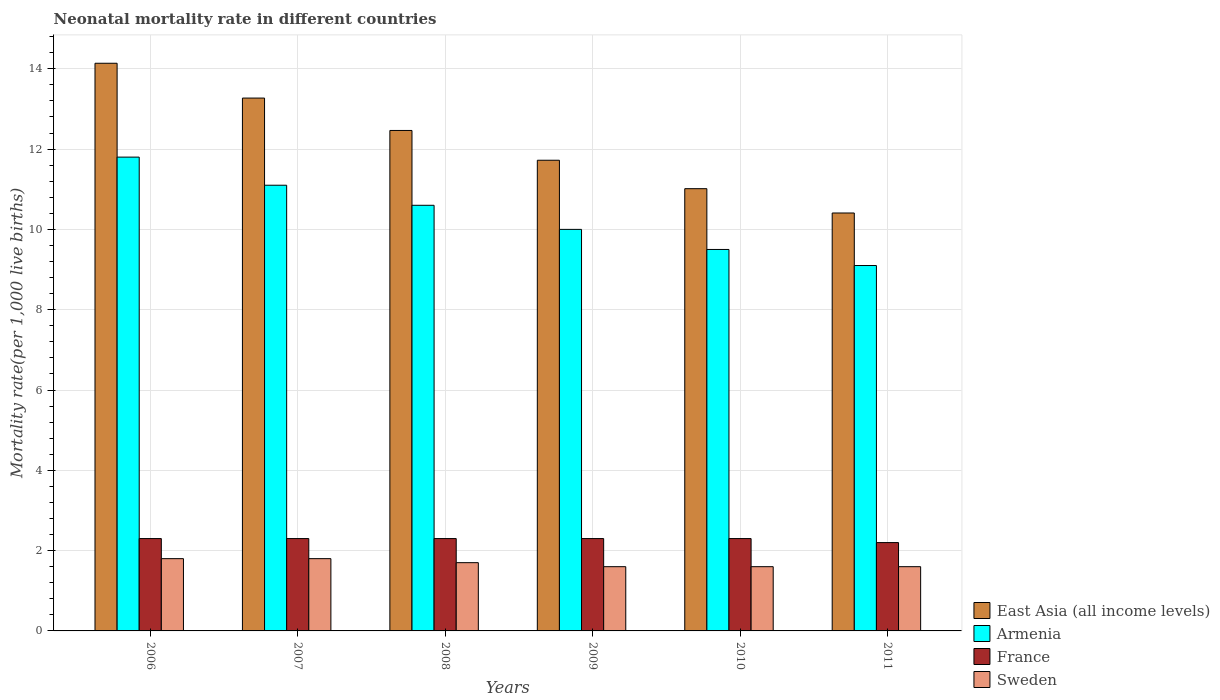How many different coloured bars are there?
Offer a very short reply. 4. How many groups of bars are there?
Keep it short and to the point. 6. How many bars are there on the 6th tick from the right?
Give a very brief answer. 4. What is the neonatal mortality rate in East Asia (all income levels) in 2006?
Provide a short and direct response. 14.14. Across all years, what is the minimum neonatal mortality rate in Armenia?
Your answer should be compact. 9.1. In which year was the neonatal mortality rate in Sweden maximum?
Your answer should be very brief. 2006. In which year was the neonatal mortality rate in France minimum?
Your response must be concise. 2011. What is the total neonatal mortality rate in East Asia (all income levels) in the graph?
Keep it short and to the point. 73.02. What is the difference between the neonatal mortality rate in France in 2008 and that in 2009?
Give a very brief answer. 0. What is the difference between the neonatal mortality rate in Sweden in 2010 and the neonatal mortality rate in Armenia in 2009?
Offer a terse response. -8.4. What is the average neonatal mortality rate in France per year?
Provide a succinct answer. 2.28. In the year 2011, what is the difference between the neonatal mortality rate in France and neonatal mortality rate in Armenia?
Provide a succinct answer. -6.9. In how many years, is the neonatal mortality rate in France greater than 8.4?
Ensure brevity in your answer.  0. What is the ratio of the neonatal mortality rate in Armenia in 2007 to that in 2008?
Provide a short and direct response. 1.05. Is the neonatal mortality rate in France in 2009 less than that in 2010?
Your answer should be very brief. No. What is the difference between the highest and the second highest neonatal mortality rate in East Asia (all income levels)?
Your answer should be very brief. 0.87. What is the difference between the highest and the lowest neonatal mortality rate in Sweden?
Your response must be concise. 0.2. Is the sum of the neonatal mortality rate in Sweden in 2006 and 2008 greater than the maximum neonatal mortality rate in France across all years?
Provide a succinct answer. Yes. What does the 4th bar from the left in 2007 represents?
Give a very brief answer. Sweden. How many years are there in the graph?
Offer a terse response. 6. Are the values on the major ticks of Y-axis written in scientific E-notation?
Give a very brief answer. No. Does the graph contain any zero values?
Provide a short and direct response. No. Does the graph contain grids?
Your response must be concise. Yes. Where does the legend appear in the graph?
Ensure brevity in your answer.  Bottom right. How are the legend labels stacked?
Your answer should be very brief. Vertical. What is the title of the graph?
Offer a terse response. Neonatal mortality rate in different countries. What is the label or title of the X-axis?
Give a very brief answer. Years. What is the label or title of the Y-axis?
Offer a very short reply. Mortality rate(per 1,0 live births). What is the Mortality rate(per 1,000 live births) in East Asia (all income levels) in 2006?
Give a very brief answer. 14.14. What is the Mortality rate(per 1,000 live births) in Armenia in 2006?
Make the answer very short. 11.8. What is the Mortality rate(per 1,000 live births) of East Asia (all income levels) in 2007?
Make the answer very short. 13.27. What is the Mortality rate(per 1,000 live births) of East Asia (all income levels) in 2008?
Offer a very short reply. 12.46. What is the Mortality rate(per 1,000 live births) in Armenia in 2008?
Your answer should be very brief. 10.6. What is the Mortality rate(per 1,000 live births) of East Asia (all income levels) in 2009?
Your answer should be very brief. 11.72. What is the Mortality rate(per 1,000 live births) of France in 2009?
Give a very brief answer. 2.3. What is the Mortality rate(per 1,000 live births) in Sweden in 2009?
Your response must be concise. 1.6. What is the Mortality rate(per 1,000 live births) in East Asia (all income levels) in 2010?
Your answer should be very brief. 11.01. What is the Mortality rate(per 1,000 live births) of Armenia in 2010?
Your response must be concise. 9.5. What is the Mortality rate(per 1,000 live births) of France in 2010?
Offer a very short reply. 2.3. What is the Mortality rate(per 1,000 live births) of Sweden in 2010?
Your answer should be compact. 1.6. What is the Mortality rate(per 1,000 live births) in East Asia (all income levels) in 2011?
Provide a short and direct response. 10.41. What is the Mortality rate(per 1,000 live births) of France in 2011?
Your answer should be compact. 2.2. What is the Mortality rate(per 1,000 live births) of Sweden in 2011?
Offer a very short reply. 1.6. Across all years, what is the maximum Mortality rate(per 1,000 live births) of East Asia (all income levels)?
Your response must be concise. 14.14. Across all years, what is the maximum Mortality rate(per 1,000 live births) of Armenia?
Ensure brevity in your answer.  11.8. Across all years, what is the maximum Mortality rate(per 1,000 live births) of France?
Ensure brevity in your answer.  2.3. Across all years, what is the maximum Mortality rate(per 1,000 live births) in Sweden?
Provide a short and direct response. 1.8. Across all years, what is the minimum Mortality rate(per 1,000 live births) in East Asia (all income levels)?
Your answer should be compact. 10.41. Across all years, what is the minimum Mortality rate(per 1,000 live births) of Armenia?
Your response must be concise. 9.1. Across all years, what is the minimum Mortality rate(per 1,000 live births) of France?
Offer a terse response. 2.2. Across all years, what is the minimum Mortality rate(per 1,000 live births) in Sweden?
Provide a short and direct response. 1.6. What is the total Mortality rate(per 1,000 live births) in East Asia (all income levels) in the graph?
Ensure brevity in your answer.  73.02. What is the total Mortality rate(per 1,000 live births) of Armenia in the graph?
Provide a short and direct response. 62.1. What is the difference between the Mortality rate(per 1,000 live births) of East Asia (all income levels) in 2006 and that in 2007?
Your response must be concise. 0.87. What is the difference between the Mortality rate(per 1,000 live births) in France in 2006 and that in 2007?
Provide a short and direct response. 0. What is the difference between the Mortality rate(per 1,000 live births) of Sweden in 2006 and that in 2007?
Keep it short and to the point. 0. What is the difference between the Mortality rate(per 1,000 live births) of East Asia (all income levels) in 2006 and that in 2008?
Your answer should be very brief. 1.67. What is the difference between the Mortality rate(per 1,000 live births) in Sweden in 2006 and that in 2008?
Provide a short and direct response. 0.1. What is the difference between the Mortality rate(per 1,000 live births) of East Asia (all income levels) in 2006 and that in 2009?
Give a very brief answer. 2.42. What is the difference between the Mortality rate(per 1,000 live births) of Armenia in 2006 and that in 2009?
Your answer should be very brief. 1.8. What is the difference between the Mortality rate(per 1,000 live births) of Sweden in 2006 and that in 2009?
Make the answer very short. 0.2. What is the difference between the Mortality rate(per 1,000 live births) in East Asia (all income levels) in 2006 and that in 2010?
Offer a very short reply. 3.12. What is the difference between the Mortality rate(per 1,000 live births) in Armenia in 2006 and that in 2010?
Ensure brevity in your answer.  2.3. What is the difference between the Mortality rate(per 1,000 live births) in East Asia (all income levels) in 2006 and that in 2011?
Your response must be concise. 3.73. What is the difference between the Mortality rate(per 1,000 live births) in Sweden in 2006 and that in 2011?
Offer a terse response. 0.2. What is the difference between the Mortality rate(per 1,000 live births) of East Asia (all income levels) in 2007 and that in 2008?
Make the answer very short. 0.81. What is the difference between the Mortality rate(per 1,000 live births) in France in 2007 and that in 2008?
Give a very brief answer. 0. What is the difference between the Mortality rate(per 1,000 live births) of East Asia (all income levels) in 2007 and that in 2009?
Provide a short and direct response. 1.55. What is the difference between the Mortality rate(per 1,000 live births) in Armenia in 2007 and that in 2009?
Offer a very short reply. 1.1. What is the difference between the Mortality rate(per 1,000 live births) in France in 2007 and that in 2009?
Your response must be concise. 0. What is the difference between the Mortality rate(per 1,000 live births) of Sweden in 2007 and that in 2009?
Your answer should be very brief. 0.2. What is the difference between the Mortality rate(per 1,000 live births) of East Asia (all income levels) in 2007 and that in 2010?
Offer a terse response. 2.26. What is the difference between the Mortality rate(per 1,000 live births) of Armenia in 2007 and that in 2010?
Keep it short and to the point. 1.6. What is the difference between the Mortality rate(per 1,000 live births) in France in 2007 and that in 2010?
Your answer should be very brief. 0. What is the difference between the Mortality rate(per 1,000 live births) of East Asia (all income levels) in 2007 and that in 2011?
Ensure brevity in your answer.  2.86. What is the difference between the Mortality rate(per 1,000 live births) of Armenia in 2007 and that in 2011?
Give a very brief answer. 2. What is the difference between the Mortality rate(per 1,000 live births) in France in 2007 and that in 2011?
Provide a succinct answer. 0.1. What is the difference between the Mortality rate(per 1,000 live births) in Sweden in 2007 and that in 2011?
Your response must be concise. 0.2. What is the difference between the Mortality rate(per 1,000 live births) of East Asia (all income levels) in 2008 and that in 2009?
Offer a terse response. 0.74. What is the difference between the Mortality rate(per 1,000 live births) of East Asia (all income levels) in 2008 and that in 2010?
Provide a short and direct response. 1.45. What is the difference between the Mortality rate(per 1,000 live births) in Armenia in 2008 and that in 2010?
Your response must be concise. 1.1. What is the difference between the Mortality rate(per 1,000 live births) in Sweden in 2008 and that in 2010?
Provide a succinct answer. 0.1. What is the difference between the Mortality rate(per 1,000 live births) in East Asia (all income levels) in 2008 and that in 2011?
Offer a very short reply. 2.06. What is the difference between the Mortality rate(per 1,000 live births) in France in 2008 and that in 2011?
Keep it short and to the point. 0.1. What is the difference between the Mortality rate(per 1,000 live births) in East Asia (all income levels) in 2009 and that in 2010?
Your answer should be very brief. 0.71. What is the difference between the Mortality rate(per 1,000 live births) of Armenia in 2009 and that in 2010?
Your response must be concise. 0.5. What is the difference between the Mortality rate(per 1,000 live births) of France in 2009 and that in 2010?
Your answer should be very brief. 0. What is the difference between the Mortality rate(per 1,000 live births) in East Asia (all income levels) in 2009 and that in 2011?
Offer a terse response. 1.31. What is the difference between the Mortality rate(per 1,000 live births) in France in 2009 and that in 2011?
Your answer should be very brief. 0.1. What is the difference between the Mortality rate(per 1,000 live births) of Sweden in 2009 and that in 2011?
Offer a terse response. 0. What is the difference between the Mortality rate(per 1,000 live births) of East Asia (all income levels) in 2010 and that in 2011?
Your answer should be compact. 0.61. What is the difference between the Mortality rate(per 1,000 live births) in East Asia (all income levels) in 2006 and the Mortality rate(per 1,000 live births) in Armenia in 2007?
Offer a terse response. 3.04. What is the difference between the Mortality rate(per 1,000 live births) in East Asia (all income levels) in 2006 and the Mortality rate(per 1,000 live births) in France in 2007?
Give a very brief answer. 11.84. What is the difference between the Mortality rate(per 1,000 live births) in East Asia (all income levels) in 2006 and the Mortality rate(per 1,000 live births) in Sweden in 2007?
Give a very brief answer. 12.34. What is the difference between the Mortality rate(per 1,000 live births) in Armenia in 2006 and the Mortality rate(per 1,000 live births) in France in 2007?
Keep it short and to the point. 9.5. What is the difference between the Mortality rate(per 1,000 live births) in France in 2006 and the Mortality rate(per 1,000 live births) in Sweden in 2007?
Your answer should be compact. 0.5. What is the difference between the Mortality rate(per 1,000 live births) in East Asia (all income levels) in 2006 and the Mortality rate(per 1,000 live births) in Armenia in 2008?
Your answer should be very brief. 3.54. What is the difference between the Mortality rate(per 1,000 live births) in East Asia (all income levels) in 2006 and the Mortality rate(per 1,000 live births) in France in 2008?
Your answer should be very brief. 11.84. What is the difference between the Mortality rate(per 1,000 live births) of East Asia (all income levels) in 2006 and the Mortality rate(per 1,000 live births) of Sweden in 2008?
Offer a terse response. 12.44. What is the difference between the Mortality rate(per 1,000 live births) of Armenia in 2006 and the Mortality rate(per 1,000 live births) of France in 2008?
Your response must be concise. 9.5. What is the difference between the Mortality rate(per 1,000 live births) of France in 2006 and the Mortality rate(per 1,000 live births) of Sweden in 2008?
Provide a succinct answer. 0.6. What is the difference between the Mortality rate(per 1,000 live births) in East Asia (all income levels) in 2006 and the Mortality rate(per 1,000 live births) in Armenia in 2009?
Your response must be concise. 4.14. What is the difference between the Mortality rate(per 1,000 live births) in East Asia (all income levels) in 2006 and the Mortality rate(per 1,000 live births) in France in 2009?
Ensure brevity in your answer.  11.84. What is the difference between the Mortality rate(per 1,000 live births) in East Asia (all income levels) in 2006 and the Mortality rate(per 1,000 live births) in Sweden in 2009?
Your response must be concise. 12.54. What is the difference between the Mortality rate(per 1,000 live births) in Armenia in 2006 and the Mortality rate(per 1,000 live births) in France in 2009?
Your answer should be compact. 9.5. What is the difference between the Mortality rate(per 1,000 live births) in East Asia (all income levels) in 2006 and the Mortality rate(per 1,000 live births) in Armenia in 2010?
Provide a short and direct response. 4.64. What is the difference between the Mortality rate(per 1,000 live births) in East Asia (all income levels) in 2006 and the Mortality rate(per 1,000 live births) in France in 2010?
Your response must be concise. 11.84. What is the difference between the Mortality rate(per 1,000 live births) in East Asia (all income levels) in 2006 and the Mortality rate(per 1,000 live births) in Sweden in 2010?
Your answer should be compact. 12.54. What is the difference between the Mortality rate(per 1,000 live births) in Armenia in 2006 and the Mortality rate(per 1,000 live births) in France in 2010?
Your answer should be compact. 9.5. What is the difference between the Mortality rate(per 1,000 live births) of Armenia in 2006 and the Mortality rate(per 1,000 live births) of Sweden in 2010?
Keep it short and to the point. 10.2. What is the difference between the Mortality rate(per 1,000 live births) in France in 2006 and the Mortality rate(per 1,000 live births) in Sweden in 2010?
Make the answer very short. 0.7. What is the difference between the Mortality rate(per 1,000 live births) in East Asia (all income levels) in 2006 and the Mortality rate(per 1,000 live births) in Armenia in 2011?
Make the answer very short. 5.04. What is the difference between the Mortality rate(per 1,000 live births) in East Asia (all income levels) in 2006 and the Mortality rate(per 1,000 live births) in France in 2011?
Your response must be concise. 11.94. What is the difference between the Mortality rate(per 1,000 live births) of East Asia (all income levels) in 2006 and the Mortality rate(per 1,000 live births) of Sweden in 2011?
Make the answer very short. 12.54. What is the difference between the Mortality rate(per 1,000 live births) of Armenia in 2006 and the Mortality rate(per 1,000 live births) of France in 2011?
Offer a terse response. 9.6. What is the difference between the Mortality rate(per 1,000 live births) of East Asia (all income levels) in 2007 and the Mortality rate(per 1,000 live births) of Armenia in 2008?
Provide a succinct answer. 2.67. What is the difference between the Mortality rate(per 1,000 live births) in East Asia (all income levels) in 2007 and the Mortality rate(per 1,000 live births) in France in 2008?
Give a very brief answer. 10.97. What is the difference between the Mortality rate(per 1,000 live births) in East Asia (all income levels) in 2007 and the Mortality rate(per 1,000 live births) in Sweden in 2008?
Your answer should be compact. 11.57. What is the difference between the Mortality rate(per 1,000 live births) of France in 2007 and the Mortality rate(per 1,000 live births) of Sweden in 2008?
Offer a terse response. 0.6. What is the difference between the Mortality rate(per 1,000 live births) in East Asia (all income levels) in 2007 and the Mortality rate(per 1,000 live births) in Armenia in 2009?
Keep it short and to the point. 3.27. What is the difference between the Mortality rate(per 1,000 live births) in East Asia (all income levels) in 2007 and the Mortality rate(per 1,000 live births) in France in 2009?
Your answer should be compact. 10.97. What is the difference between the Mortality rate(per 1,000 live births) of East Asia (all income levels) in 2007 and the Mortality rate(per 1,000 live births) of Sweden in 2009?
Keep it short and to the point. 11.67. What is the difference between the Mortality rate(per 1,000 live births) of France in 2007 and the Mortality rate(per 1,000 live births) of Sweden in 2009?
Keep it short and to the point. 0.7. What is the difference between the Mortality rate(per 1,000 live births) of East Asia (all income levels) in 2007 and the Mortality rate(per 1,000 live births) of Armenia in 2010?
Ensure brevity in your answer.  3.77. What is the difference between the Mortality rate(per 1,000 live births) of East Asia (all income levels) in 2007 and the Mortality rate(per 1,000 live births) of France in 2010?
Make the answer very short. 10.97. What is the difference between the Mortality rate(per 1,000 live births) in East Asia (all income levels) in 2007 and the Mortality rate(per 1,000 live births) in Sweden in 2010?
Your response must be concise. 11.67. What is the difference between the Mortality rate(per 1,000 live births) in East Asia (all income levels) in 2007 and the Mortality rate(per 1,000 live births) in Armenia in 2011?
Keep it short and to the point. 4.17. What is the difference between the Mortality rate(per 1,000 live births) in East Asia (all income levels) in 2007 and the Mortality rate(per 1,000 live births) in France in 2011?
Offer a very short reply. 11.07. What is the difference between the Mortality rate(per 1,000 live births) of East Asia (all income levels) in 2007 and the Mortality rate(per 1,000 live births) of Sweden in 2011?
Make the answer very short. 11.67. What is the difference between the Mortality rate(per 1,000 live births) in East Asia (all income levels) in 2008 and the Mortality rate(per 1,000 live births) in Armenia in 2009?
Ensure brevity in your answer.  2.46. What is the difference between the Mortality rate(per 1,000 live births) of East Asia (all income levels) in 2008 and the Mortality rate(per 1,000 live births) of France in 2009?
Offer a terse response. 10.16. What is the difference between the Mortality rate(per 1,000 live births) in East Asia (all income levels) in 2008 and the Mortality rate(per 1,000 live births) in Sweden in 2009?
Provide a succinct answer. 10.86. What is the difference between the Mortality rate(per 1,000 live births) in Armenia in 2008 and the Mortality rate(per 1,000 live births) in Sweden in 2009?
Your response must be concise. 9. What is the difference between the Mortality rate(per 1,000 live births) of East Asia (all income levels) in 2008 and the Mortality rate(per 1,000 live births) of Armenia in 2010?
Your answer should be compact. 2.96. What is the difference between the Mortality rate(per 1,000 live births) in East Asia (all income levels) in 2008 and the Mortality rate(per 1,000 live births) in France in 2010?
Make the answer very short. 10.16. What is the difference between the Mortality rate(per 1,000 live births) of East Asia (all income levels) in 2008 and the Mortality rate(per 1,000 live births) of Sweden in 2010?
Offer a very short reply. 10.86. What is the difference between the Mortality rate(per 1,000 live births) of East Asia (all income levels) in 2008 and the Mortality rate(per 1,000 live births) of Armenia in 2011?
Offer a very short reply. 3.36. What is the difference between the Mortality rate(per 1,000 live births) in East Asia (all income levels) in 2008 and the Mortality rate(per 1,000 live births) in France in 2011?
Offer a terse response. 10.26. What is the difference between the Mortality rate(per 1,000 live births) in East Asia (all income levels) in 2008 and the Mortality rate(per 1,000 live births) in Sweden in 2011?
Your response must be concise. 10.86. What is the difference between the Mortality rate(per 1,000 live births) in Armenia in 2008 and the Mortality rate(per 1,000 live births) in Sweden in 2011?
Provide a short and direct response. 9. What is the difference between the Mortality rate(per 1,000 live births) in France in 2008 and the Mortality rate(per 1,000 live births) in Sweden in 2011?
Provide a succinct answer. 0.7. What is the difference between the Mortality rate(per 1,000 live births) in East Asia (all income levels) in 2009 and the Mortality rate(per 1,000 live births) in Armenia in 2010?
Your answer should be very brief. 2.22. What is the difference between the Mortality rate(per 1,000 live births) of East Asia (all income levels) in 2009 and the Mortality rate(per 1,000 live births) of France in 2010?
Ensure brevity in your answer.  9.42. What is the difference between the Mortality rate(per 1,000 live births) of East Asia (all income levels) in 2009 and the Mortality rate(per 1,000 live births) of Sweden in 2010?
Offer a terse response. 10.12. What is the difference between the Mortality rate(per 1,000 live births) of Armenia in 2009 and the Mortality rate(per 1,000 live births) of France in 2010?
Ensure brevity in your answer.  7.7. What is the difference between the Mortality rate(per 1,000 live births) in France in 2009 and the Mortality rate(per 1,000 live births) in Sweden in 2010?
Keep it short and to the point. 0.7. What is the difference between the Mortality rate(per 1,000 live births) of East Asia (all income levels) in 2009 and the Mortality rate(per 1,000 live births) of Armenia in 2011?
Your response must be concise. 2.62. What is the difference between the Mortality rate(per 1,000 live births) in East Asia (all income levels) in 2009 and the Mortality rate(per 1,000 live births) in France in 2011?
Offer a terse response. 9.52. What is the difference between the Mortality rate(per 1,000 live births) of East Asia (all income levels) in 2009 and the Mortality rate(per 1,000 live births) of Sweden in 2011?
Ensure brevity in your answer.  10.12. What is the difference between the Mortality rate(per 1,000 live births) in France in 2009 and the Mortality rate(per 1,000 live births) in Sweden in 2011?
Give a very brief answer. 0.7. What is the difference between the Mortality rate(per 1,000 live births) in East Asia (all income levels) in 2010 and the Mortality rate(per 1,000 live births) in Armenia in 2011?
Your response must be concise. 1.91. What is the difference between the Mortality rate(per 1,000 live births) of East Asia (all income levels) in 2010 and the Mortality rate(per 1,000 live births) of France in 2011?
Offer a very short reply. 8.81. What is the difference between the Mortality rate(per 1,000 live births) of East Asia (all income levels) in 2010 and the Mortality rate(per 1,000 live births) of Sweden in 2011?
Your response must be concise. 9.41. What is the average Mortality rate(per 1,000 live births) in East Asia (all income levels) per year?
Keep it short and to the point. 12.17. What is the average Mortality rate(per 1,000 live births) in Armenia per year?
Provide a short and direct response. 10.35. What is the average Mortality rate(per 1,000 live births) in France per year?
Offer a terse response. 2.28. What is the average Mortality rate(per 1,000 live births) of Sweden per year?
Give a very brief answer. 1.68. In the year 2006, what is the difference between the Mortality rate(per 1,000 live births) in East Asia (all income levels) and Mortality rate(per 1,000 live births) in Armenia?
Offer a terse response. 2.34. In the year 2006, what is the difference between the Mortality rate(per 1,000 live births) of East Asia (all income levels) and Mortality rate(per 1,000 live births) of France?
Your response must be concise. 11.84. In the year 2006, what is the difference between the Mortality rate(per 1,000 live births) in East Asia (all income levels) and Mortality rate(per 1,000 live births) in Sweden?
Provide a short and direct response. 12.34. In the year 2006, what is the difference between the Mortality rate(per 1,000 live births) in Armenia and Mortality rate(per 1,000 live births) in Sweden?
Ensure brevity in your answer.  10. In the year 2006, what is the difference between the Mortality rate(per 1,000 live births) of France and Mortality rate(per 1,000 live births) of Sweden?
Ensure brevity in your answer.  0.5. In the year 2007, what is the difference between the Mortality rate(per 1,000 live births) in East Asia (all income levels) and Mortality rate(per 1,000 live births) in Armenia?
Your response must be concise. 2.17. In the year 2007, what is the difference between the Mortality rate(per 1,000 live births) of East Asia (all income levels) and Mortality rate(per 1,000 live births) of France?
Ensure brevity in your answer.  10.97. In the year 2007, what is the difference between the Mortality rate(per 1,000 live births) in East Asia (all income levels) and Mortality rate(per 1,000 live births) in Sweden?
Make the answer very short. 11.47. In the year 2007, what is the difference between the Mortality rate(per 1,000 live births) of Armenia and Mortality rate(per 1,000 live births) of France?
Make the answer very short. 8.8. In the year 2008, what is the difference between the Mortality rate(per 1,000 live births) of East Asia (all income levels) and Mortality rate(per 1,000 live births) of Armenia?
Ensure brevity in your answer.  1.86. In the year 2008, what is the difference between the Mortality rate(per 1,000 live births) in East Asia (all income levels) and Mortality rate(per 1,000 live births) in France?
Your answer should be compact. 10.16. In the year 2008, what is the difference between the Mortality rate(per 1,000 live births) in East Asia (all income levels) and Mortality rate(per 1,000 live births) in Sweden?
Give a very brief answer. 10.76. In the year 2009, what is the difference between the Mortality rate(per 1,000 live births) in East Asia (all income levels) and Mortality rate(per 1,000 live births) in Armenia?
Offer a very short reply. 1.72. In the year 2009, what is the difference between the Mortality rate(per 1,000 live births) of East Asia (all income levels) and Mortality rate(per 1,000 live births) of France?
Your answer should be compact. 9.42. In the year 2009, what is the difference between the Mortality rate(per 1,000 live births) of East Asia (all income levels) and Mortality rate(per 1,000 live births) of Sweden?
Offer a very short reply. 10.12. In the year 2009, what is the difference between the Mortality rate(per 1,000 live births) of Armenia and Mortality rate(per 1,000 live births) of France?
Give a very brief answer. 7.7. In the year 2010, what is the difference between the Mortality rate(per 1,000 live births) in East Asia (all income levels) and Mortality rate(per 1,000 live births) in Armenia?
Ensure brevity in your answer.  1.51. In the year 2010, what is the difference between the Mortality rate(per 1,000 live births) of East Asia (all income levels) and Mortality rate(per 1,000 live births) of France?
Offer a terse response. 8.71. In the year 2010, what is the difference between the Mortality rate(per 1,000 live births) in East Asia (all income levels) and Mortality rate(per 1,000 live births) in Sweden?
Make the answer very short. 9.41. In the year 2010, what is the difference between the Mortality rate(per 1,000 live births) in Armenia and Mortality rate(per 1,000 live births) in France?
Provide a short and direct response. 7.2. In the year 2011, what is the difference between the Mortality rate(per 1,000 live births) in East Asia (all income levels) and Mortality rate(per 1,000 live births) in Armenia?
Offer a terse response. 1.31. In the year 2011, what is the difference between the Mortality rate(per 1,000 live births) in East Asia (all income levels) and Mortality rate(per 1,000 live births) in France?
Ensure brevity in your answer.  8.21. In the year 2011, what is the difference between the Mortality rate(per 1,000 live births) in East Asia (all income levels) and Mortality rate(per 1,000 live births) in Sweden?
Provide a succinct answer. 8.81. In the year 2011, what is the difference between the Mortality rate(per 1,000 live births) of Armenia and Mortality rate(per 1,000 live births) of France?
Ensure brevity in your answer.  6.9. In the year 2011, what is the difference between the Mortality rate(per 1,000 live births) in Armenia and Mortality rate(per 1,000 live births) in Sweden?
Your response must be concise. 7.5. In the year 2011, what is the difference between the Mortality rate(per 1,000 live births) of France and Mortality rate(per 1,000 live births) of Sweden?
Your answer should be compact. 0.6. What is the ratio of the Mortality rate(per 1,000 live births) of East Asia (all income levels) in 2006 to that in 2007?
Your response must be concise. 1.07. What is the ratio of the Mortality rate(per 1,000 live births) in Armenia in 2006 to that in 2007?
Ensure brevity in your answer.  1.06. What is the ratio of the Mortality rate(per 1,000 live births) in East Asia (all income levels) in 2006 to that in 2008?
Make the answer very short. 1.13. What is the ratio of the Mortality rate(per 1,000 live births) of Armenia in 2006 to that in 2008?
Your answer should be very brief. 1.11. What is the ratio of the Mortality rate(per 1,000 live births) of France in 2006 to that in 2008?
Give a very brief answer. 1. What is the ratio of the Mortality rate(per 1,000 live births) of Sweden in 2006 to that in 2008?
Offer a terse response. 1.06. What is the ratio of the Mortality rate(per 1,000 live births) of East Asia (all income levels) in 2006 to that in 2009?
Offer a terse response. 1.21. What is the ratio of the Mortality rate(per 1,000 live births) in Armenia in 2006 to that in 2009?
Your answer should be compact. 1.18. What is the ratio of the Mortality rate(per 1,000 live births) of Sweden in 2006 to that in 2009?
Offer a terse response. 1.12. What is the ratio of the Mortality rate(per 1,000 live births) in East Asia (all income levels) in 2006 to that in 2010?
Keep it short and to the point. 1.28. What is the ratio of the Mortality rate(per 1,000 live births) in Armenia in 2006 to that in 2010?
Offer a very short reply. 1.24. What is the ratio of the Mortality rate(per 1,000 live births) of France in 2006 to that in 2010?
Your answer should be very brief. 1. What is the ratio of the Mortality rate(per 1,000 live births) of Sweden in 2006 to that in 2010?
Ensure brevity in your answer.  1.12. What is the ratio of the Mortality rate(per 1,000 live births) of East Asia (all income levels) in 2006 to that in 2011?
Offer a very short reply. 1.36. What is the ratio of the Mortality rate(per 1,000 live births) of Armenia in 2006 to that in 2011?
Keep it short and to the point. 1.3. What is the ratio of the Mortality rate(per 1,000 live births) in France in 2006 to that in 2011?
Make the answer very short. 1.05. What is the ratio of the Mortality rate(per 1,000 live births) of East Asia (all income levels) in 2007 to that in 2008?
Ensure brevity in your answer.  1.06. What is the ratio of the Mortality rate(per 1,000 live births) of Armenia in 2007 to that in 2008?
Make the answer very short. 1.05. What is the ratio of the Mortality rate(per 1,000 live births) in Sweden in 2007 to that in 2008?
Offer a very short reply. 1.06. What is the ratio of the Mortality rate(per 1,000 live births) in East Asia (all income levels) in 2007 to that in 2009?
Give a very brief answer. 1.13. What is the ratio of the Mortality rate(per 1,000 live births) of Armenia in 2007 to that in 2009?
Provide a succinct answer. 1.11. What is the ratio of the Mortality rate(per 1,000 live births) in Sweden in 2007 to that in 2009?
Your answer should be very brief. 1.12. What is the ratio of the Mortality rate(per 1,000 live births) in East Asia (all income levels) in 2007 to that in 2010?
Your answer should be very brief. 1.2. What is the ratio of the Mortality rate(per 1,000 live births) of Armenia in 2007 to that in 2010?
Provide a short and direct response. 1.17. What is the ratio of the Mortality rate(per 1,000 live births) of France in 2007 to that in 2010?
Provide a succinct answer. 1. What is the ratio of the Mortality rate(per 1,000 live births) of East Asia (all income levels) in 2007 to that in 2011?
Provide a short and direct response. 1.27. What is the ratio of the Mortality rate(per 1,000 live births) of Armenia in 2007 to that in 2011?
Offer a terse response. 1.22. What is the ratio of the Mortality rate(per 1,000 live births) of France in 2007 to that in 2011?
Provide a short and direct response. 1.05. What is the ratio of the Mortality rate(per 1,000 live births) in Sweden in 2007 to that in 2011?
Give a very brief answer. 1.12. What is the ratio of the Mortality rate(per 1,000 live births) in East Asia (all income levels) in 2008 to that in 2009?
Keep it short and to the point. 1.06. What is the ratio of the Mortality rate(per 1,000 live births) of Armenia in 2008 to that in 2009?
Offer a very short reply. 1.06. What is the ratio of the Mortality rate(per 1,000 live births) of East Asia (all income levels) in 2008 to that in 2010?
Your answer should be very brief. 1.13. What is the ratio of the Mortality rate(per 1,000 live births) in Armenia in 2008 to that in 2010?
Your answer should be very brief. 1.12. What is the ratio of the Mortality rate(per 1,000 live births) of France in 2008 to that in 2010?
Your answer should be very brief. 1. What is the ratio of the Mortality rate(per 1,000 live births) in Sweden in 2008 to that in 2010?
Make the answer very short. 1.06. What is the ratio of the Mortality rate(per 1,000 live births) in East Asia (all income levels) in 2008 to that in 2011?
Keep it short and to the point. 1.2. What is the ratio of the Mortality rate(per 1,000 live births) in Armenia in 2008 to that in 2011?
Provide a succinct answer. 1.16. What is the ratio of the Mortality rate(per 1,000 live births) in France in 2008 to that in 2011?
Provide a short and direct response. 1.05. What is the ratio of the Mortality rate(per 1,000 live births) of East Asia (all income levels) in 2009 to that in 2010?
Ensure brevity in your answer.  1.06. What is the ratio of the Mortality rate(per 1,000 live births) in Armenia in 2009 to that in 2010?
Offer a terse response. 1.05. What is the ratio of the Mortality rate(per 1,000 live births) of East Asia (all income levels) in 2009 to that in 2011?
Offer a terse response. 1.13. What is the ratio of the Mortality rate(per 1,000 live births) in Armenia in 2009 to that in 2011?
Provide a succinct answer. 1.1. What is the ratio of the Mortality rate(per 1,000 live births) in France in 2009 to that in 2011?
Offer a terse response. 1.05. What is the ratio of the Mortality rate(per 1,000 live births) in Sweden in 2009 to that in 2011?
Provide a succinct answer. 1. What is the ratio of the Mortality rate(per 1,000 live births) in East Asia (all income levels) in 2010 to that in 2011?
Your answer should be compact. 1.06. What is the ratio of the Mortality rate(per 1,000 live births) of Armenia in 2010 to that in 2011?
Ensure brevity in your answer.  1.04. What is the ratio of the Mortality rate(per 1,000 live births) of France in 2010 to that in 2011?
Keep it short and to the point. 1.05. What is the difference between the highest and the second highest Mortality rate(per 1,000 live births) of East Asia (all income levels)?
Offer a terse response. 0.87. What is the difference between the highest and the second highest Mortality rate(per 1,000 live births) in Armenia?
Give a very brief answer. 0.7. What is the difference between the highest and the second highest Mortality rate(per 1,000 live births) in France?
Your answer should be compact. 0. What is the difference between the highest and the second highest Mortality rate(per 1,000 live births) in Sweden?
Provide a succinct answer. 0. What is the difference between the highest and the lowest Mortality rate(per 1,000 live births) in East Asia (all income levels)?
Your response must be concise. 3.73. 